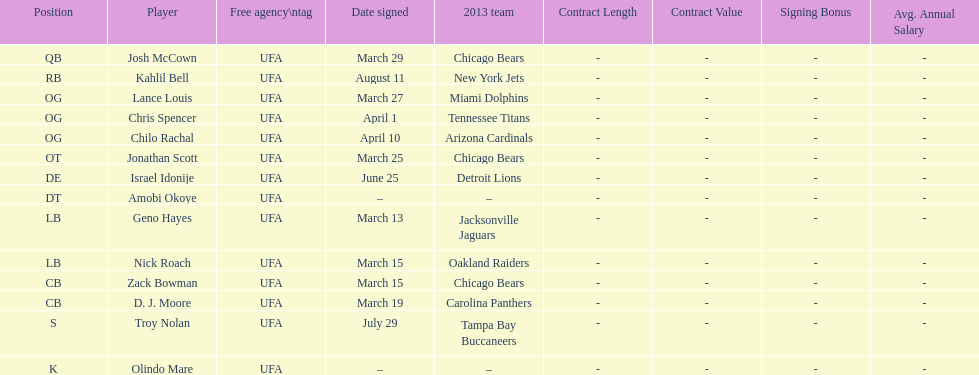The only player to sign in july? Troy Nolan. 